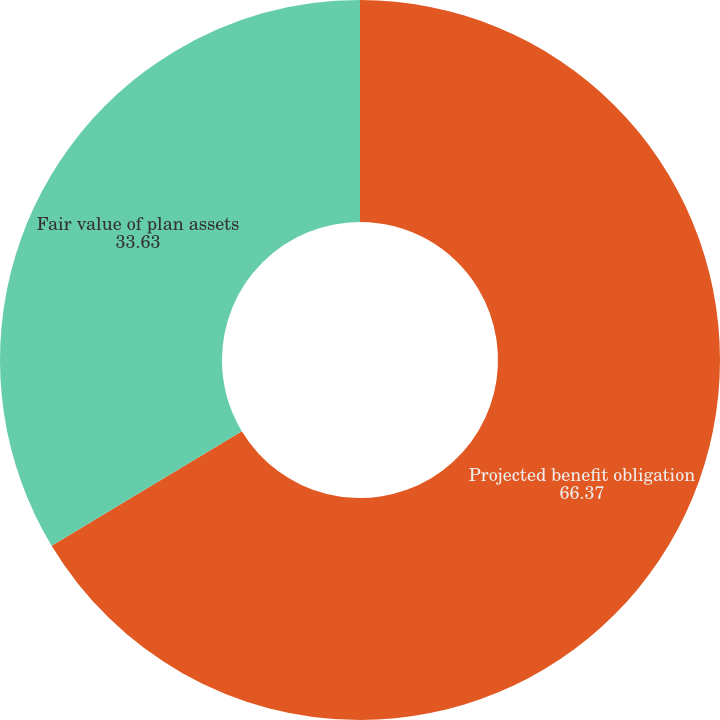Convert chart. <chart><loc_0><loc_0><loc_500><loc_500><pie_chart><fcel>Projected benefit obligation<fcel>Fair value of plan assets<nl><fcel>66.37%<fcel>33.63%<nl></chart> 